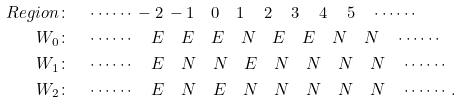<formula> <loc_0><loc_0><loc_500><loc_500>R e g i o n & \colon \quad \cdots \cdots \, - 2 \, - 1 \quad 0 \quad 1 \quad \, 2 \quad \, 3 \quad \, 4 \quad \, 5 \quad \cdots \cdots \\ W _ { 0 } & \colon \quad \cdots \cdots \quad E \quad E \quad E \quad N \quad E \quad E \quad N \quad N \quad \cdots \cdots \\ W _ { 1 } & \colon \quad \cdots \cdots \quad E \quad N \quad N \quad E \quad N \quad N \quad N \quad N \quad \cdots \cdots \\ W _ { 2 } & \colon \quad \cdots \cdots \quad E \quad N \quad E \quad N \quad N \quad N \quad N \quad N \quad \cdots \cdots .</formula> 